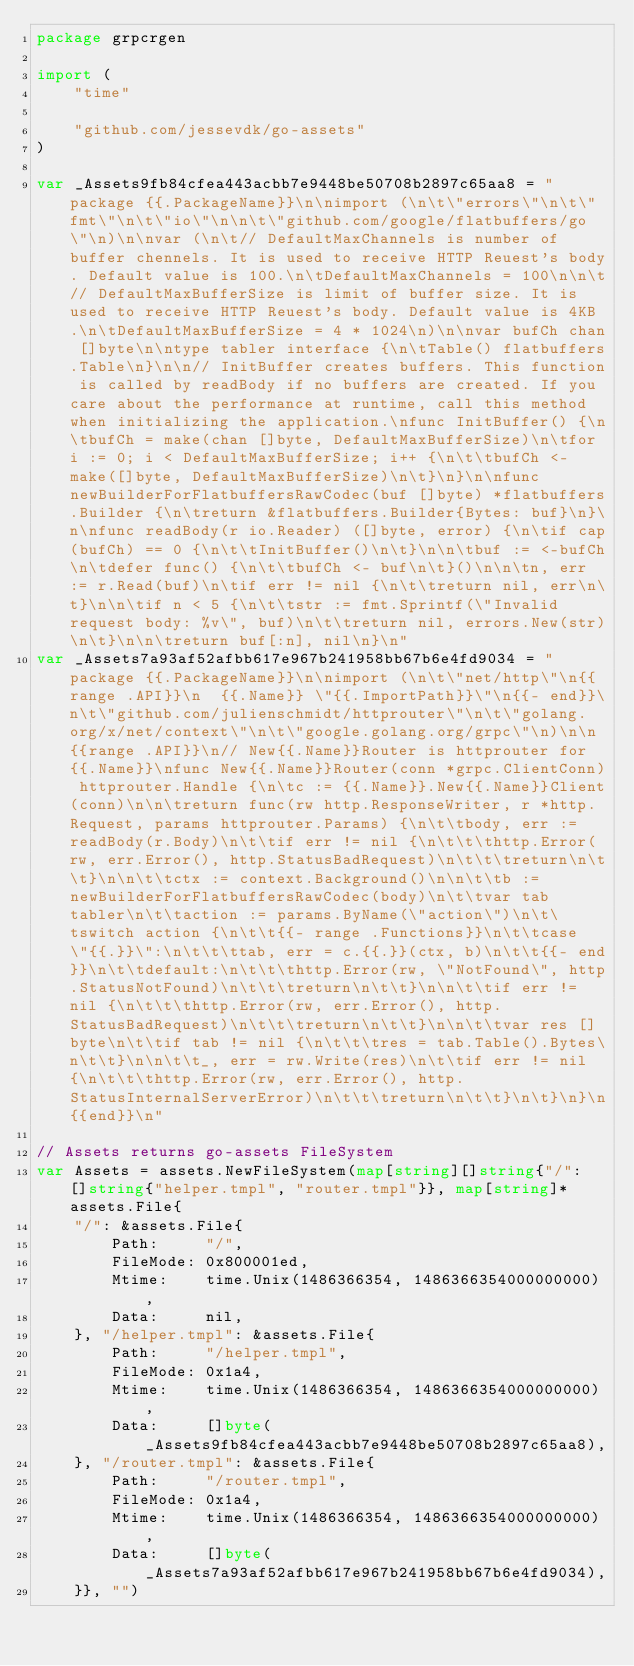Convert code to text. <code><loc_0><loc_0><loc_500><loc_500><_Go_>package grpcrgen

import (
	"time"

	"github.com/jessevdk/go-assets"
)

var _Assets9fb84cfea443acbb7e9448be50708b2897c65aa8 = "package {{.PackageName}}\n\nimport (\n\t\"errors\"\n\t\"fmt\"\n\t\"io\"\n\n\t\"github.com/google/flatbuffers/go\"\n)\n\nvar (\n\t// DefaultMaxChannels is number of buffer chennels. It is used to receive HTTP Reuest's body. Default value is 100.\n\tDefaultMaxChannels = 100\n\n\t// DefaultMaxBufferSize is limit of buffer size. It is used to receive HTTP Reuest's body. Default value is 4KB.\n\tDefaultMaxBufferSize = 4 * 1024\n)\n\nvar bufCh chan []byte\n\ntype tabler interface {\n\tTable() flatbuffers.Table\n}\n\n// InitBuffer creates buffers. This function is called by readBody if no buffers are created. If you care about the performance at runtime, call this method when initializing the application.\nfunc InitBuffer() {\n\tbufCh = make(chan []byte, DefaultMaxBufferSize)\n\tfor i := 0; i < DefaultMaxBufferSize; i++ {\n\t\tbufCh <- make([]byte, DefaultMaxBufferSize)\n\t}\n}\n\nfunc newBuilderForFlatbuffersRawCodec(buf []byte) *flatbuffers.Builder {\n\treturn &flatbuffers.Builder{Bytes: buf}\n}\n\nfunc readBody(r io.Reader) ([]byte, error) {\n\tif cap(bufCh) == 0 {\n\t\tInitBuffer()\n\t}\n\n\tbuf := <-bufCh\n\tdefer func() {\n\t\tbufCh <- buf\n\t}()\n\n\tn, err := r.Read(buf)\n\tif err != nil {\n\t\treturn nil, err\n\t}\n\n\tif n < 5 {\n\t\tstr := fmt.Sprintf(\"Invalid request body: %v\", buf)\n\t\treturn nil, errors.New(str)\n\t}\n\n\treturn buf[:n], nil\n}\n"
var _Assets7a93af52afbb617e967b241958bb67b6e4fd9034 = "package {{.PackageName}}\n\nimport (\n\t\"net/http\"\n{{range .API}}\n  {{.Name}} \"{{.ImportPath}}\"\n{{- end}}\n\t\"github.com/julienschmidt/httprouter\"\n\t\"golang.org/x/net/context\"\n\t\"google.golang.org/grpc\"\n)\n\n{{range .API}}\n// New{{.Name}}Router is httprouter for {{.Name}}\nfunc New{{.Name}}Router(conn *grpc.ClientConn) httprouter.Handle {\n\tc := {{.Name}}.New{{.Name}}Client(conn)\n\n\treturn func(rw http.ResponseWriter, r *http.Request, params httprouter.Params) {\n\t\tbody, err := readBody(r.Body)\n\t\tif err != nil {\n\t\t\thttp.Error(rw, err.Error(), http.StatusBadRequest)\n\t\t\treturn\n\t\t}\n\n\t\tctx := context.Background()\n\n\t\tb := newBuilderForFlatbuffersRawCodec(body)\n\t\tvar tab tabler\n\t\taction := params.ByName(\"action\")\n\t\tswitch action {\n\t\t{{- range .Functions}}\n\t\tcase \"{{.}}\":\n\t\t\ttab, err = c.{{.}}(ctx, b)\n\t\t{{- end}}\n\t\tdefault:\n\t\t\thttp.Error(rw, \"NotFound\", http.StatusNotFound)\n\t\t\treturn\n\t\t}\n\n\t\tif err != nil {\n\t\t\thttp.Error(rw, err.Error(), http.StatusBadRequest)\n\t\t\treturn\n\t\t}\n\n\t\tvar res []byte\n\t\tif tab != nil {\n\t\t\tres = tab.Table().Bytes\n\t\t}\n\n\t\t_, err = rw.Write(res)\n\t\tif err != nil {\n\t\t\thttp.Error(rw, err.Error(), http.StatusInternalServerError)\n\t\t\treturn\n\t\t}\n\t}\n}\n{{end}}\n"

// Assets returns go-assets FileSystem
var Assets = assets.NewFileSystem(map[string][]string{"/": []string{"helper.tmpl", "router.tmpl"}}, map[string]*assets.File{
	"/": &assets.File{
		Path:     "/",
		FileMode: 0x800001ed,
		Mtime:    time.Unix(1486366354, 1486366354000000000),
		Data:     nil,
	}, "/helper.tmpl": &assets.File{
		Path:     "/helper.tmpl",
		FileMode: 0x1a4,
		Mtime:    time.Unix(1486366354, 1486366354000000000),
		Data:     []byte(_Assets9fb84cfea443acbb7e9448be50708b2897c65aa8),
	}, "/router.tmpl": &assets.File{
		Path:     "/router.tmpl",
		FileMode: 0x1a4,
		Mtime:    time.Unix(1486366354, 1486366354000000000),
		Data:     []byte(_Assets7a93af52afbb617e967b241958bb67b6e4fd9034),
	}}, "")
</code> 